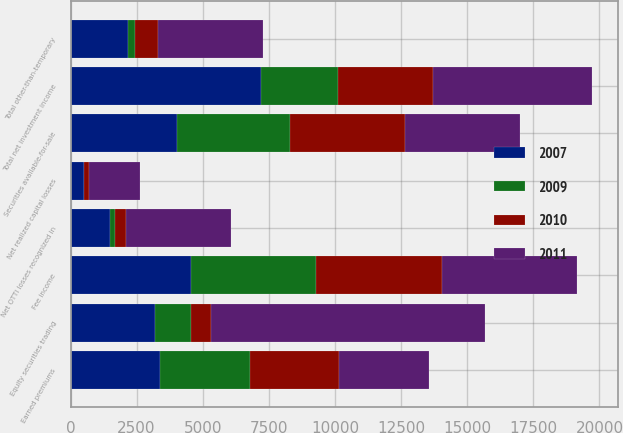<chart> <loc_0><loc_0><loc_500><loc_500><stacked_bar_chart><ecel><fcel>Earned premiums<fcel>Fee income<fcel>Securities available-for-sale<fcel>Equity securities trading<fcel>Total net investment income<fcel>Total other-than-temporary<fcel>Net OTTI losses recognized in<fcel>Net realized capital losses<nl><fcel>2009<fcel>3389<fcel>4750<fcel>4272<fcel>1359<fcel>2913<fcel>263<fcel>174<fcel>29<nl><fcel>2010<fcel>3389<fcel>4748<fcel>4364<fcel>774<fcel>3590<fcel>852<fcel>434<fcel>177<nl><fcel>2007<fcel>3389<fcel>4547<fcel>4017<fcel>3188<fcel>7205<fcel>2191<fcel>1508<fcel>496<nl><fcel>2011<fcel>3389<fcel>5103<fcel>4327<fcel>10340<fcel>6013<fcel>3964<fcel>3964<fcel>1941<nl></chart> 